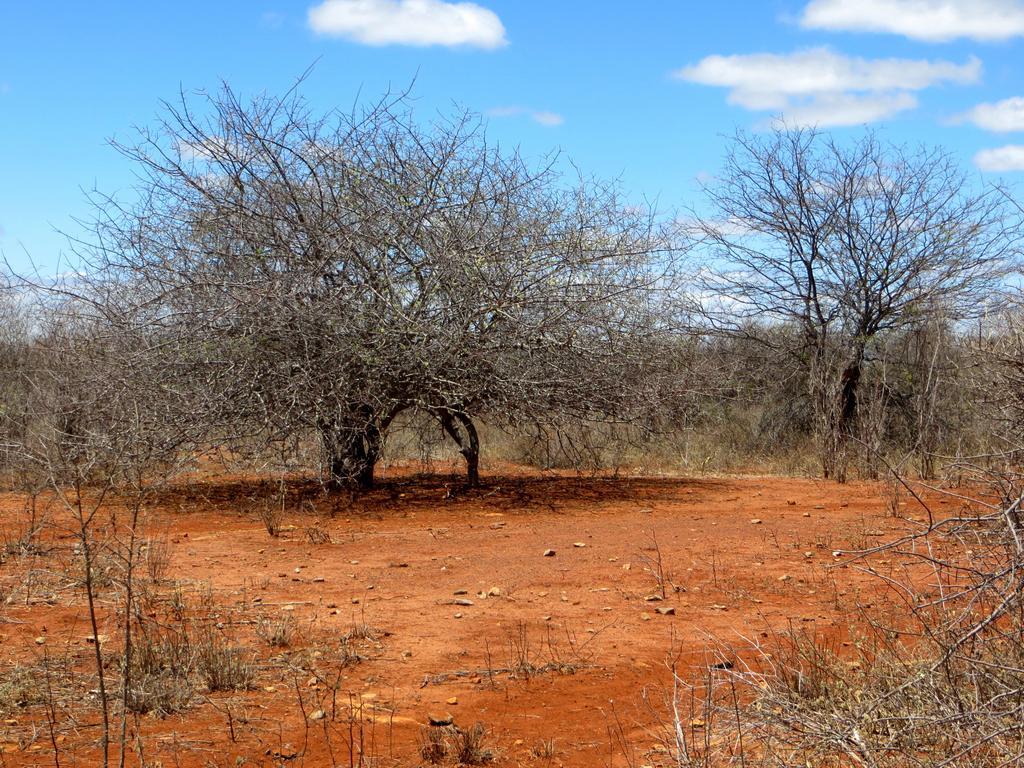How would you summarize this image in a sentence or two? In the center we can see the sky,clouds,trees,,dry grass etc. 